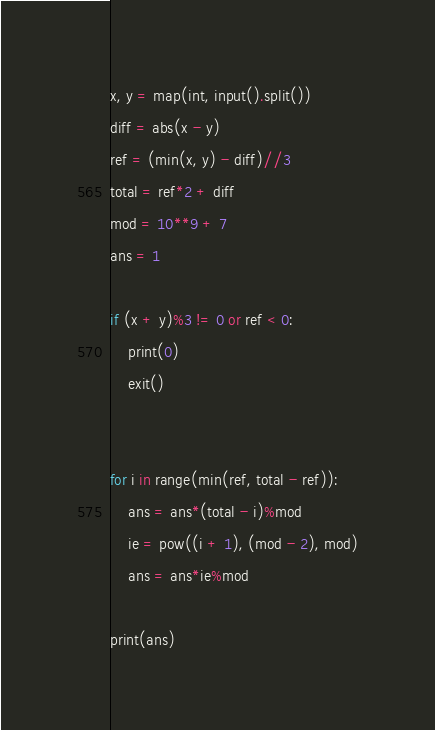<code> <loc_0><loc_0><loc_500><loc_500><_Python_>x, y = map(int, input().split())
diff = abs(x - y)
ref = (min(x, y) - diff)//3
total = ref*2 + diff
mod = 10**9 + 7
ans = 1

if (x + y)%3 != 0 or ref < 0:
    print(0)
    exit()


for i in range(min(ref, total - ref)):
    ans = ans*(total - i)%mod
    ie = pow((i + 1), (mod - 2), mod)
    ans = ans*ie%mod

print(ans)</code> 